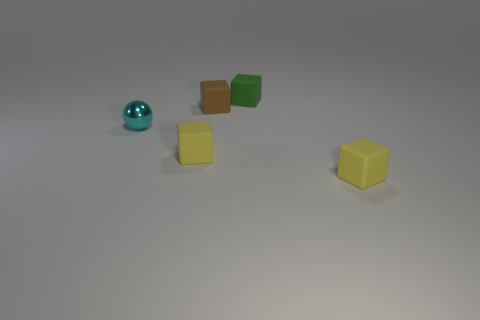Subtract all brown cubes. How many cubes are left? 3 Subtract 3 blocks. How many blocks are left? 1 Subtract all green cubes. How many cubes are left? 3 Add 3 blue rubber cylinders. How many objects exist? 8 Add 4 big yellow rubber cubes. How many big yellow rubber cubes exist? 4 Subtract 0 brown spheres. How many objects are left? 5 Subtract all spheres. How many objects are left? 4 Subtract all brown blocks. Subtract all blue spheres. How many blocks are left? 3 Subtract all green spheres. How many gray blocks are left? 0 Subtract all yellow things. Subtract all small yellow cubes. How many objects are left? 1 